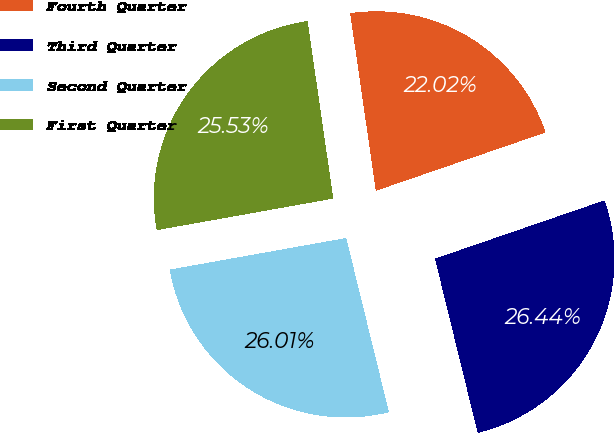Convert chart. <chart><loc_0><loc_0><loc_500><loc_500><pie_chart><fcel>Fourth Quarter<fcel>Third Quarter<fcel>Second Quarter<fcel>First Quarter<nl><fcel>22.02%<fcel>26.44%<fcel>26.01%<fcel>25.53%<nl></chart> 